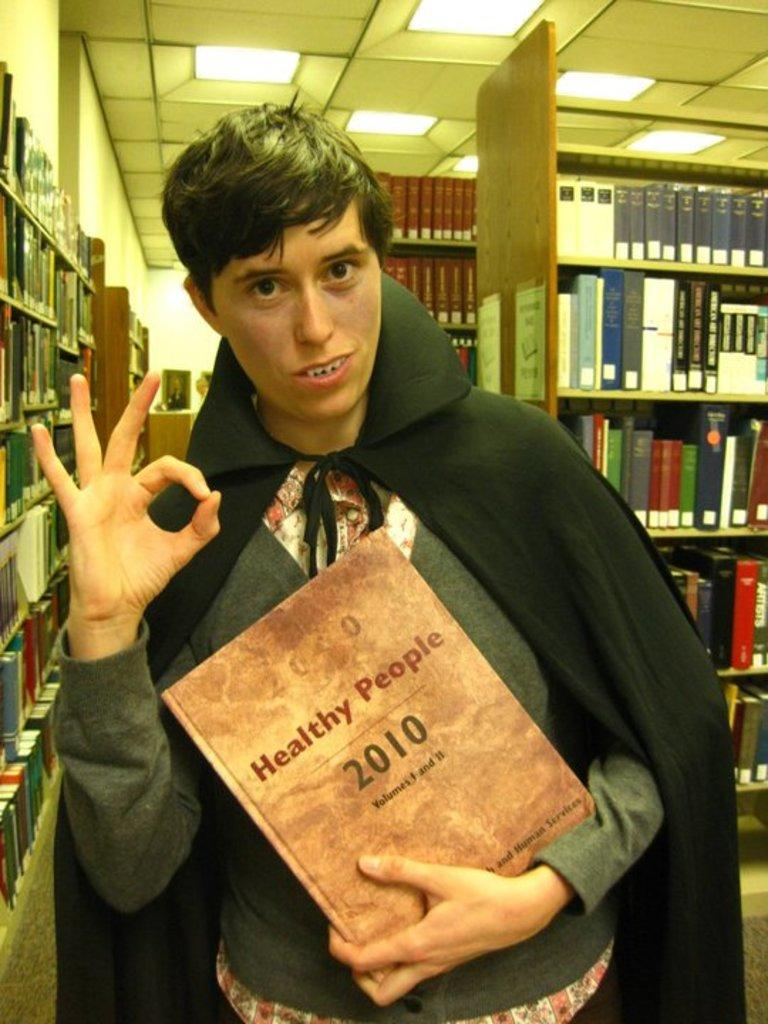<image>
Create a compact narrative representing the image presented. A young man dressed as a vampire holding a book named, "Healthy People 2010". 